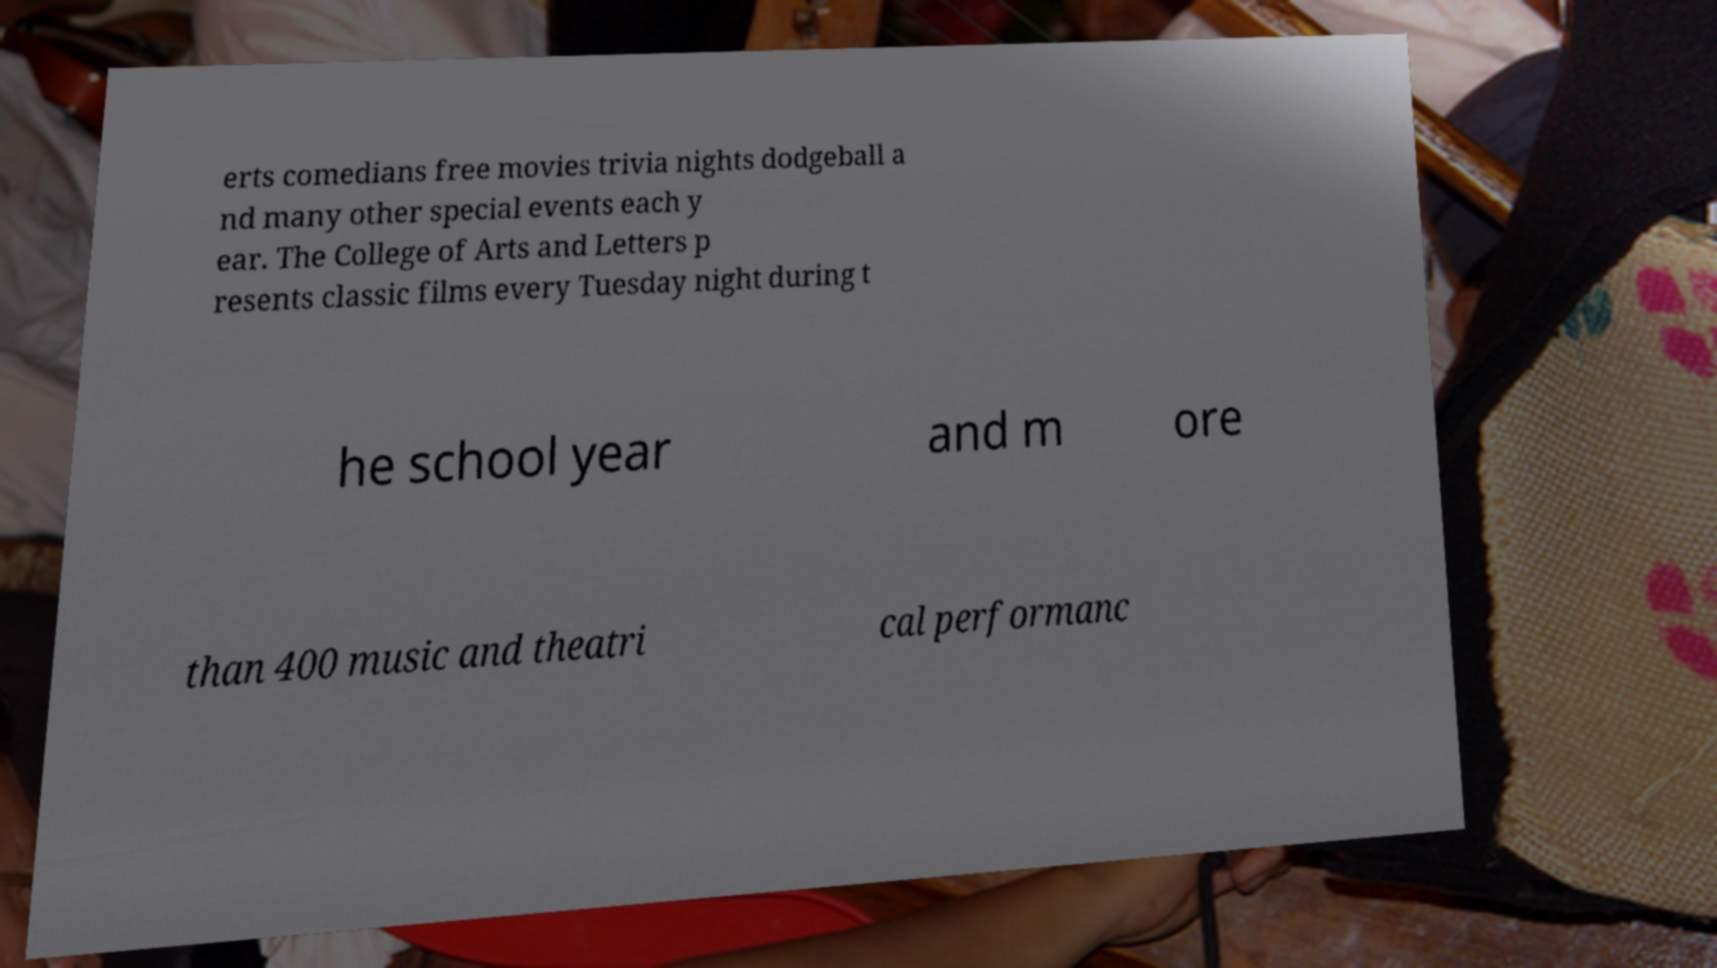Could you assist in decoding the text presented in this image and type it out clearly? erts comedians free movies trivia nights dodgeball a nd many other special events each y ear. The College of Arts and Letters p resents classic films every Tuesday night during t he school year and m ore than 400 music and theatri cal performanc 